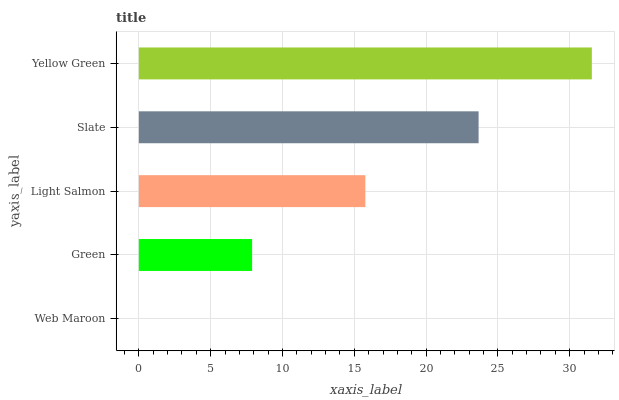Is Web Maroon the minimum?
Answer yes or no. Yes. Is Yellow Green the maximum?
Answer yes or no. Yes. Is Green the minimum?
Answer yes or no. No. Is Green the maximum?
Answer yes or no. No. Is Green greater than Web Maroon?
Answer yes or no. Yes. Is Web Maroon less than Green?
Answer yes or no. Yes. Is Web Maroon greater than Green?
Answer yes or no. No. Is Green less than Web Maroon?
Answer yes or no. No. Is Light Salmon the high median?
Answer yes or no. Yes. Is Light Salmon the low median?
Answer yes or no. Yes. Is Green the high median?
Answer yes or no. No. Is Green the low median?
Answer yes or no. No. 